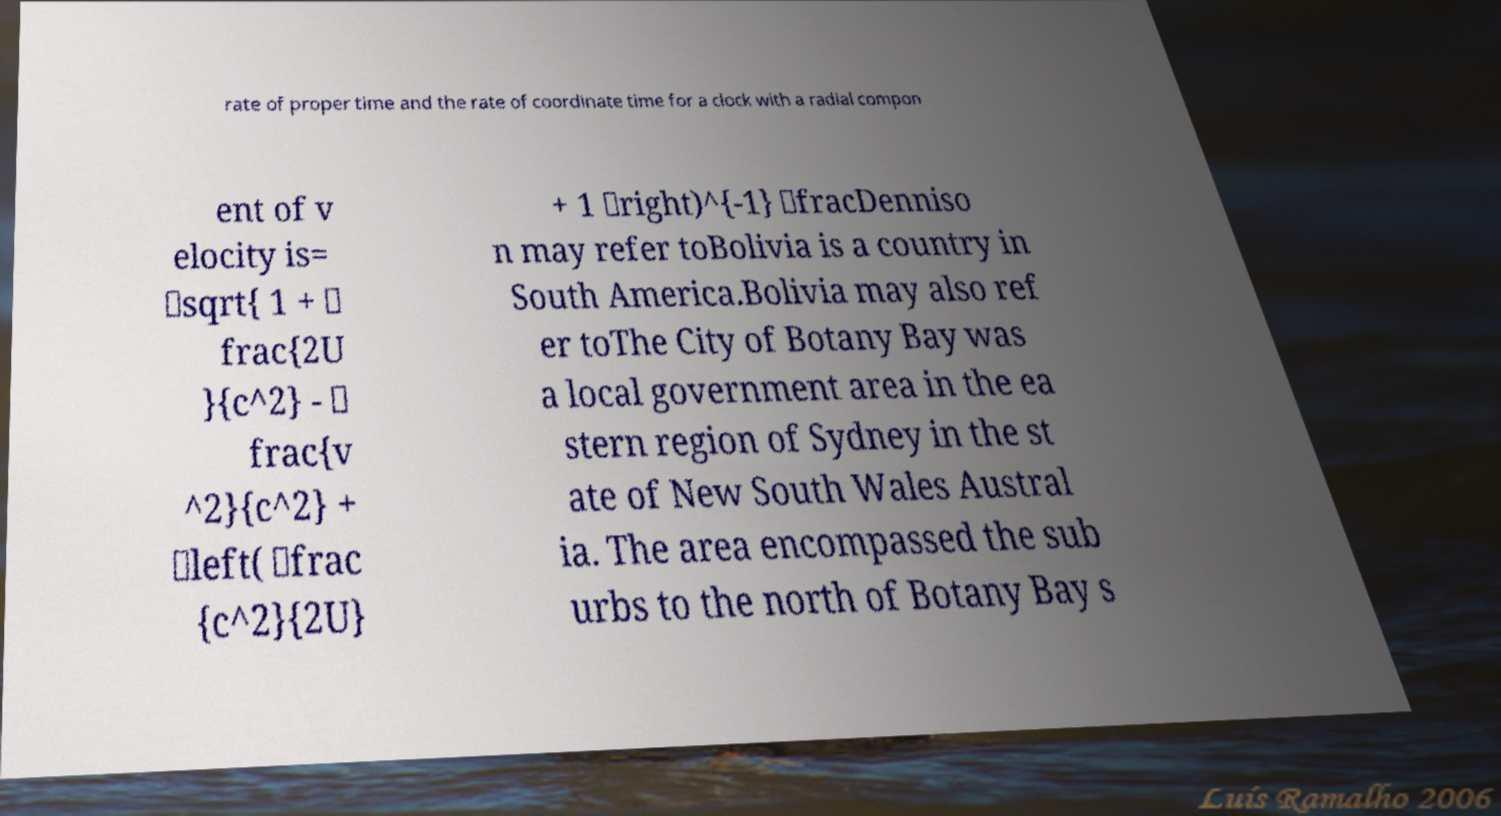Please read and relay the text visible in this image. What does it say? rate of proper time and the rate of coordinate time for a clock with a radial compon ent of v elocity is= \sqrt{ 1 + \ frac{2U }{c^2} - \ frac{v ^2}{c^2} + \left( \frac {c^2}{2U} + 1 \right)^{-1} \fracDenniso n may refer toBolivia is a country in South America.Bolivia may also ref er toThe City of Botany Bay was a local government area in the ea stern region of Sydney in the st ate of New South Wales Austral ia. The area encompassed the sub urbs to the north of Botany Bay s 